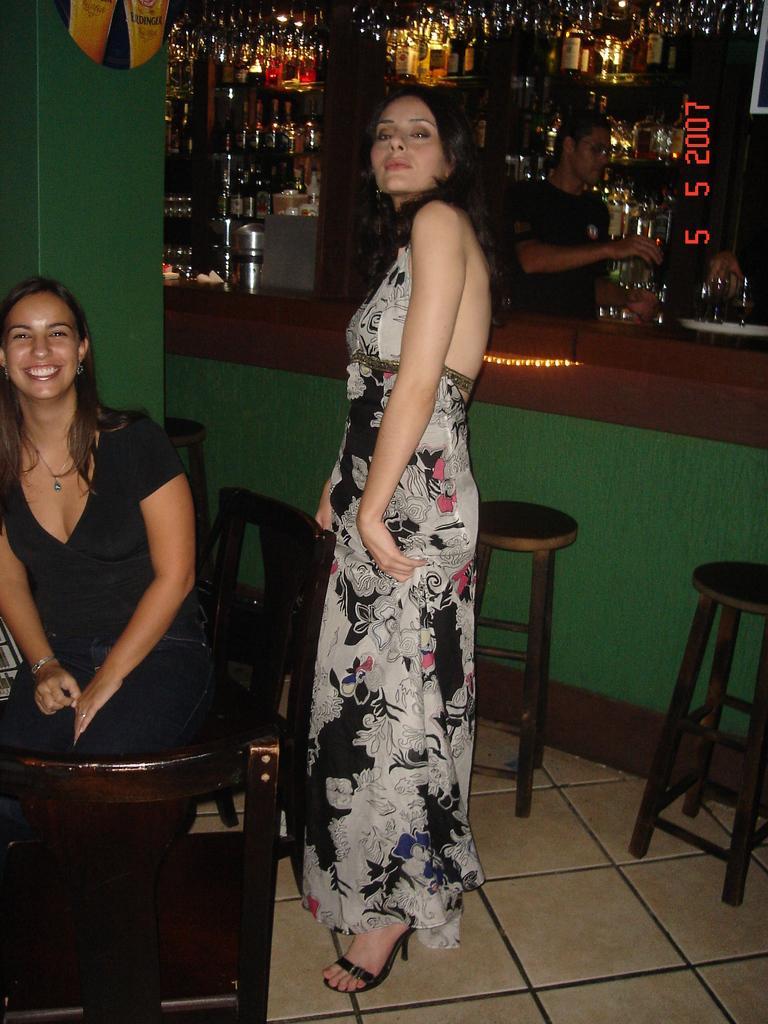Can you describe this image briefly? In the center we can see one woman standing,she is wearing white long frock. On the left there is a woman sitting and she is smiling. In the background we can see wine bottles,table,stools,chair,pillar,wall and one more woman standing. 